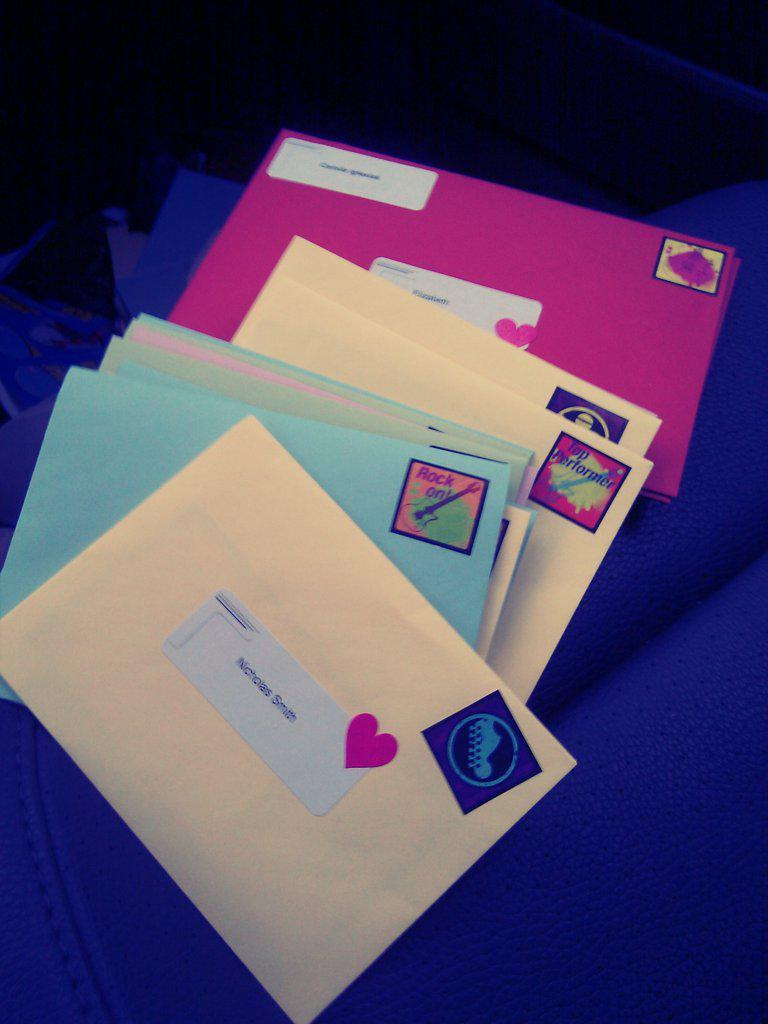<image>
Present a compact description of the photo's key features. A pile of brightly colored unopened letters are resting on a surface. 